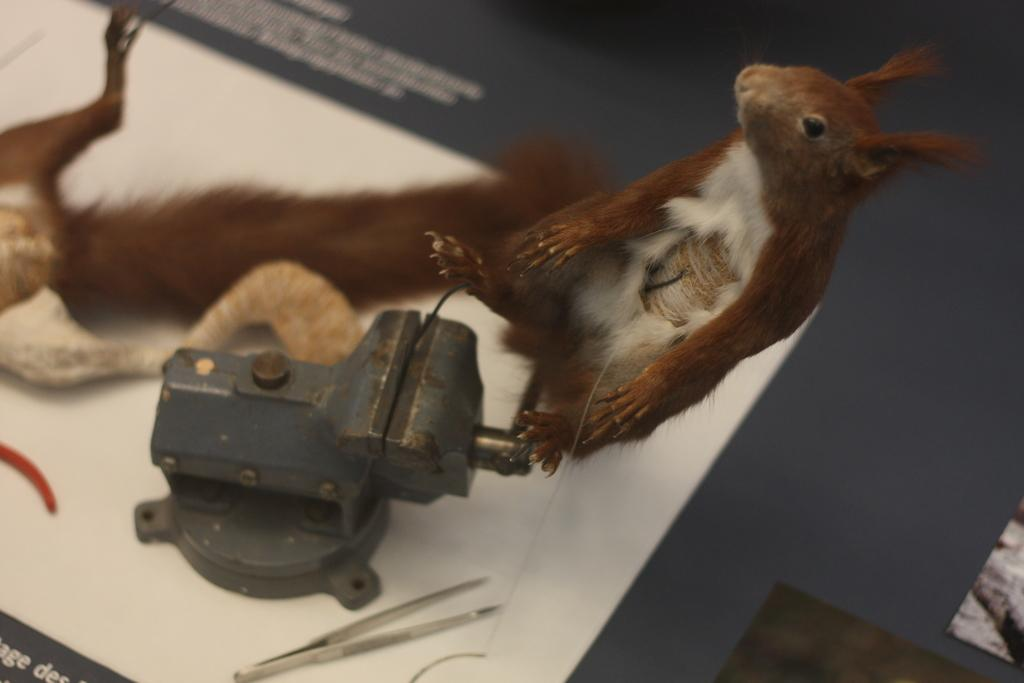What animals can be seen on the table in the image? There are two squirrels on the table in the image. What type of equipment is present in the image? There is a machine in the image. What kind of object is used for a specific purpose in the image? There is a tool in the image. Can you describe any other objects in the image? There are a few other objects in the image. What type of debt is being discussed by the squirrels in the image? There is no indication of a debt being discussed in the image, as it features two squirrels on a table with a machine, a tool, and other objects. 